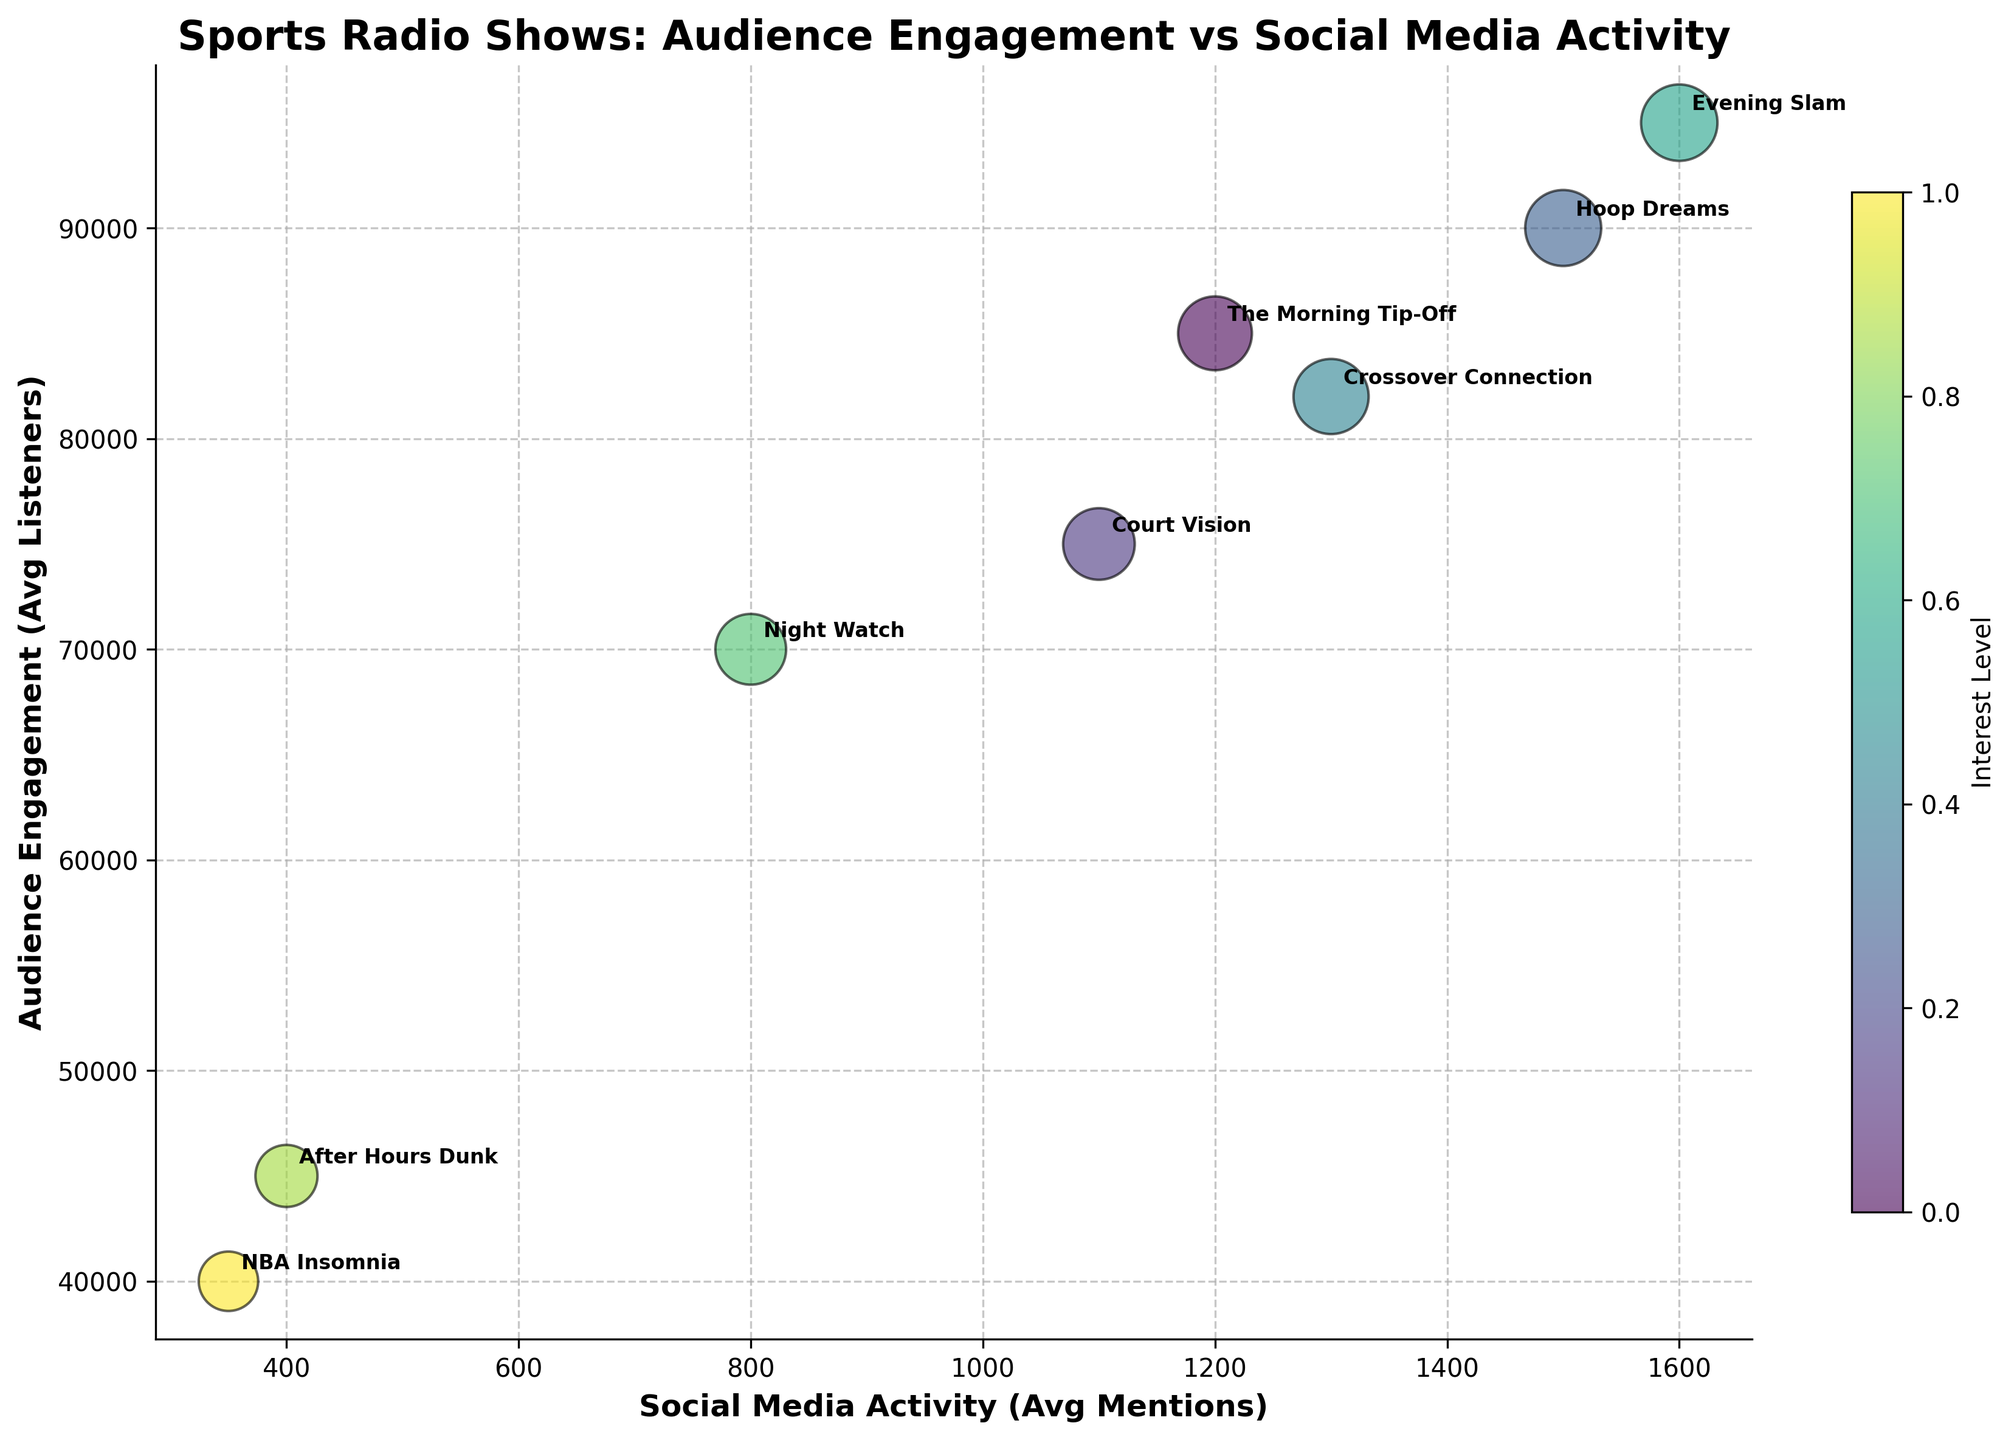What is the title of the chart? Look at the top part of the chart where the title is generally placed. The title here is "Sports Radio Shows: Audience Engagement vs Social Media Activity."
Answer: Sports Radio Shows: Audience Engagement vs Social Media Activity Which show has the highest audience engagement? We need to look at the y-axis representing 'Audience Engagement (Avg Listeners)' and identify the highest bubble along this axis. The show at the highest point is "Evening Slam."
Answer: Evening Slam What time slot has the lowest social media activity? Observe the x-axis representing 'Social Media Activity (Avg Mentions)' and find the leftmost point. The show "NBA Insomnia" has the lowest social media activity.
Answer: NBA Insomnia What is the average audience engagement for shows between 06:00-12:00? Shows between this time slot are "The Morning Tip-Off" and "Court Vision." Their audience engagements are 85,000 and 75,000. The average is (85,000 + 75,000) / 2.
Answer: 80,000 Which show has a higher interest level, "Crossover Connection" or "Night Watch"? From the color gradient indicated in the legend, "Crossover Connection" has an interest level of 0.88 and "Night Watch" has a level of 0.78. Thus, "Crossover Connection" has a higher interest level.
Answer: Crossover Connection How does audience engagement relate to social media activity across all shows? Observe the general trend in the scatter plot. Bubbles higher on the y-axis (higher audience engagement) tend to also be further right on the x-axis (higher social media activity), indicating a positive correlation.
Answer: Positive correlation What is the size of the bubble representing "Hoop Dreams"? The size of the bubble for "Hoop Dreams" can be identified by observing its proportion relative to others, which is based on 'Interest Level (Avg Engagement Score)', and "Hoop Dreams" has an interest level of 0.90.
Answer: interest level of 0.90 Which show has the most balanced distribution in terms of audience engagement and social media activity? We need to identify a bubble positioned mid-range on both axes. The "Crossover Connection" show has well-balanced audience engagement and social media activity.
Answer: Crossover Connection How does the show "After Hours Dunk" compare to "Court Vision" in terms of audience engagement? Compare the vertical positions of the bubbles representing these shows on the y-axis. "After Hours Dunk" has 45,000 average listeners, while "Court Vision" has 75,000, making "Court Vision" higher.
Answer: Court Vision has higher audience engagement Which time slot has the largest interest level? Look at the color gradient represented in the legend. "Evening Slam" from 18:00-21:00 has the highest interest level of 0.91.
Answer: 18:00-21:00 